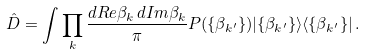Convert formula to latex. <formula><loc_0><loc_0><loc_500><loc_500>\hat { D } = \int \prod _ { k } \frac { d R e \beta _ { k } \, d I m \beta _ { k } } { \pi } P ( \{ \beta _ { k ^ { \prime } } \} ) | \{ \beta _ { k ^ { \prime } } \} \rangle \langle \{ \beta _ { k ^ { \prime } } \} | \, .</formula> 